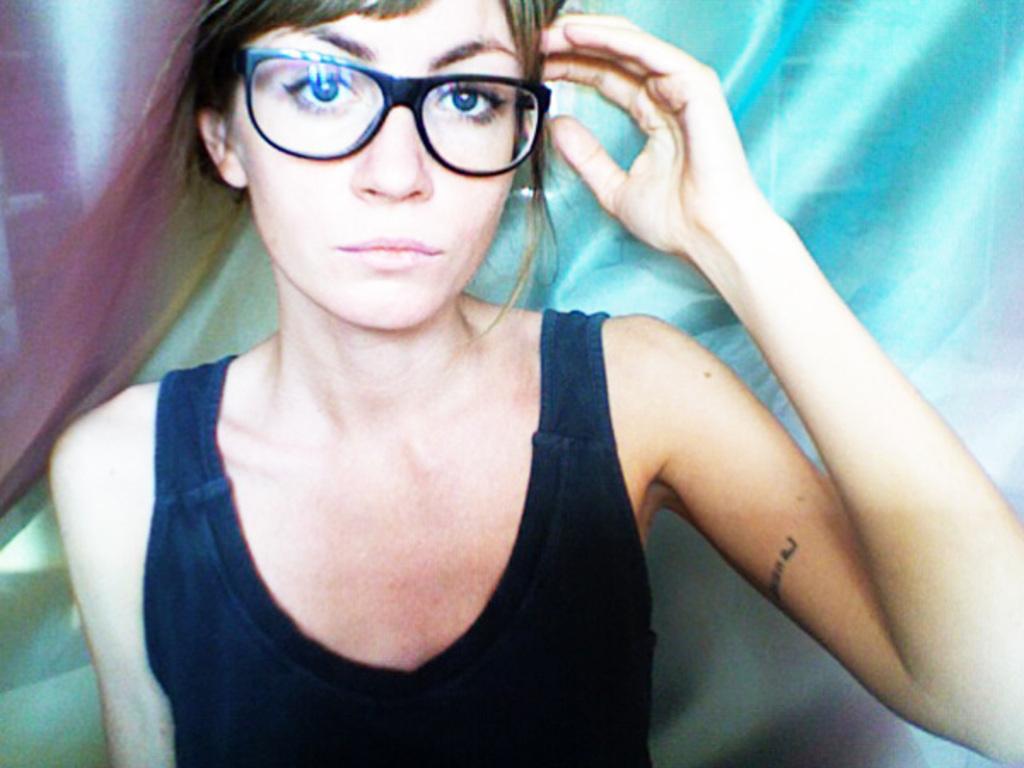Describe this image in one or two sentences. In the center of the image we can see a person in a black top. And we can see she is wearing glasses. In the background, we can see it is blurred. 